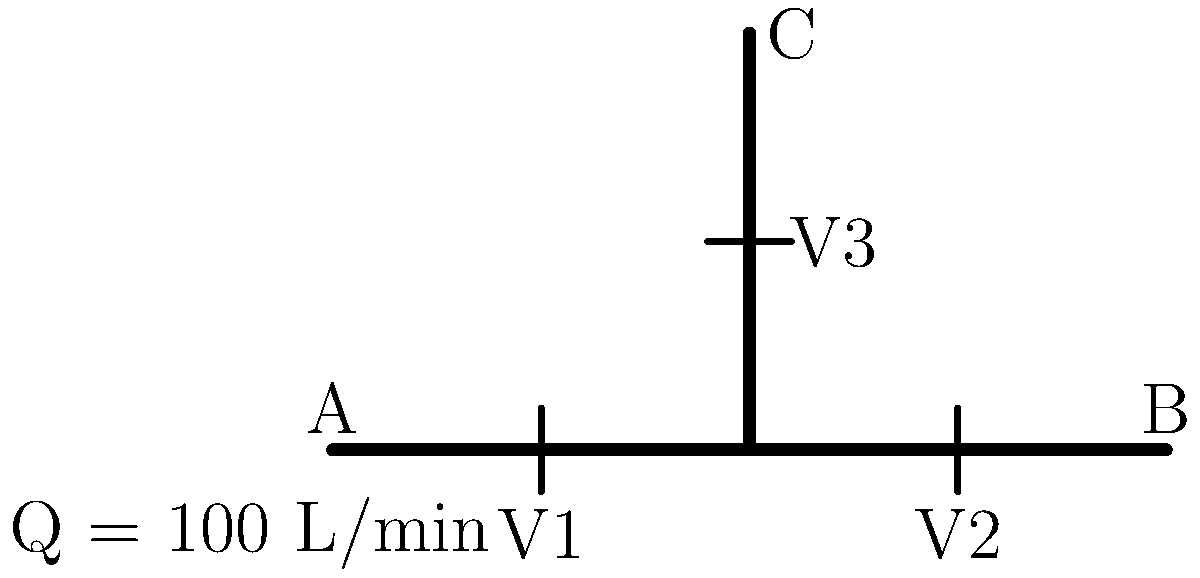In the given pipe configuration, water flows from point A to points B and C. The total flow rate at point A is 100 L/min. Valves V1, V2, and V3 are partially open, creating different levels of resistance. If the pressure drop across V1 is twice that of V2, and the pressure drop across V3 is three times that of V2, what is the flow rate at point B? Assume the pipe diameters are constant and neglect minor losses. To solve this problem, we'll use the concept that flow distributes inversely proportional to resistance in parallel paths. We can consider the pressure drops across the valves as representative of the resistance in each path.

Let's approach this step-by-step:

1) Let the resistance of V2 be R. Then:
   Resistance of V1 = 2R
   Resistance of V3 = 3R

2) The flow will split inversely proportional to these resistances. Let's call the flow through V2 (to point B) as x. Then:

   Flow through V1 = $\frac{x}{2}$ (because its resistance is twice that of V2)
   Flow through V3 = $\frac{x}{3}$ (because its resistance is three times that of V2)

3) We know the total flow is 100 L/min, so we can set up an equation:

   $\frac{x}{2} + x + \frac{x}{3} = 100$

4) Simplify the equation:

   $\frac{3x}{6} + \frac{6x}{6} + \frac{2x}{6} = 100$
   $\frac{11x}{6} = 100$

5) Solve for x:

   $x = \frac{600}{11} \approx 54.55$ L/min

Therefore, the flow rate at point B (through V2) is approximately 54.55 L/min.

This approach, while simplified, demonstrates how flow distributes in parallel paths based on the resistance in each path, which is a key concept in fluid mechanics and relevant to data privacy considerations in industrial systems.
Answer: 54.55 L/min 